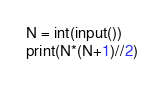<code> <loc_0><loc_0><loc_500><loc_500><_Python_>N = int(input())
print(N*(N+1)//2)</code> 